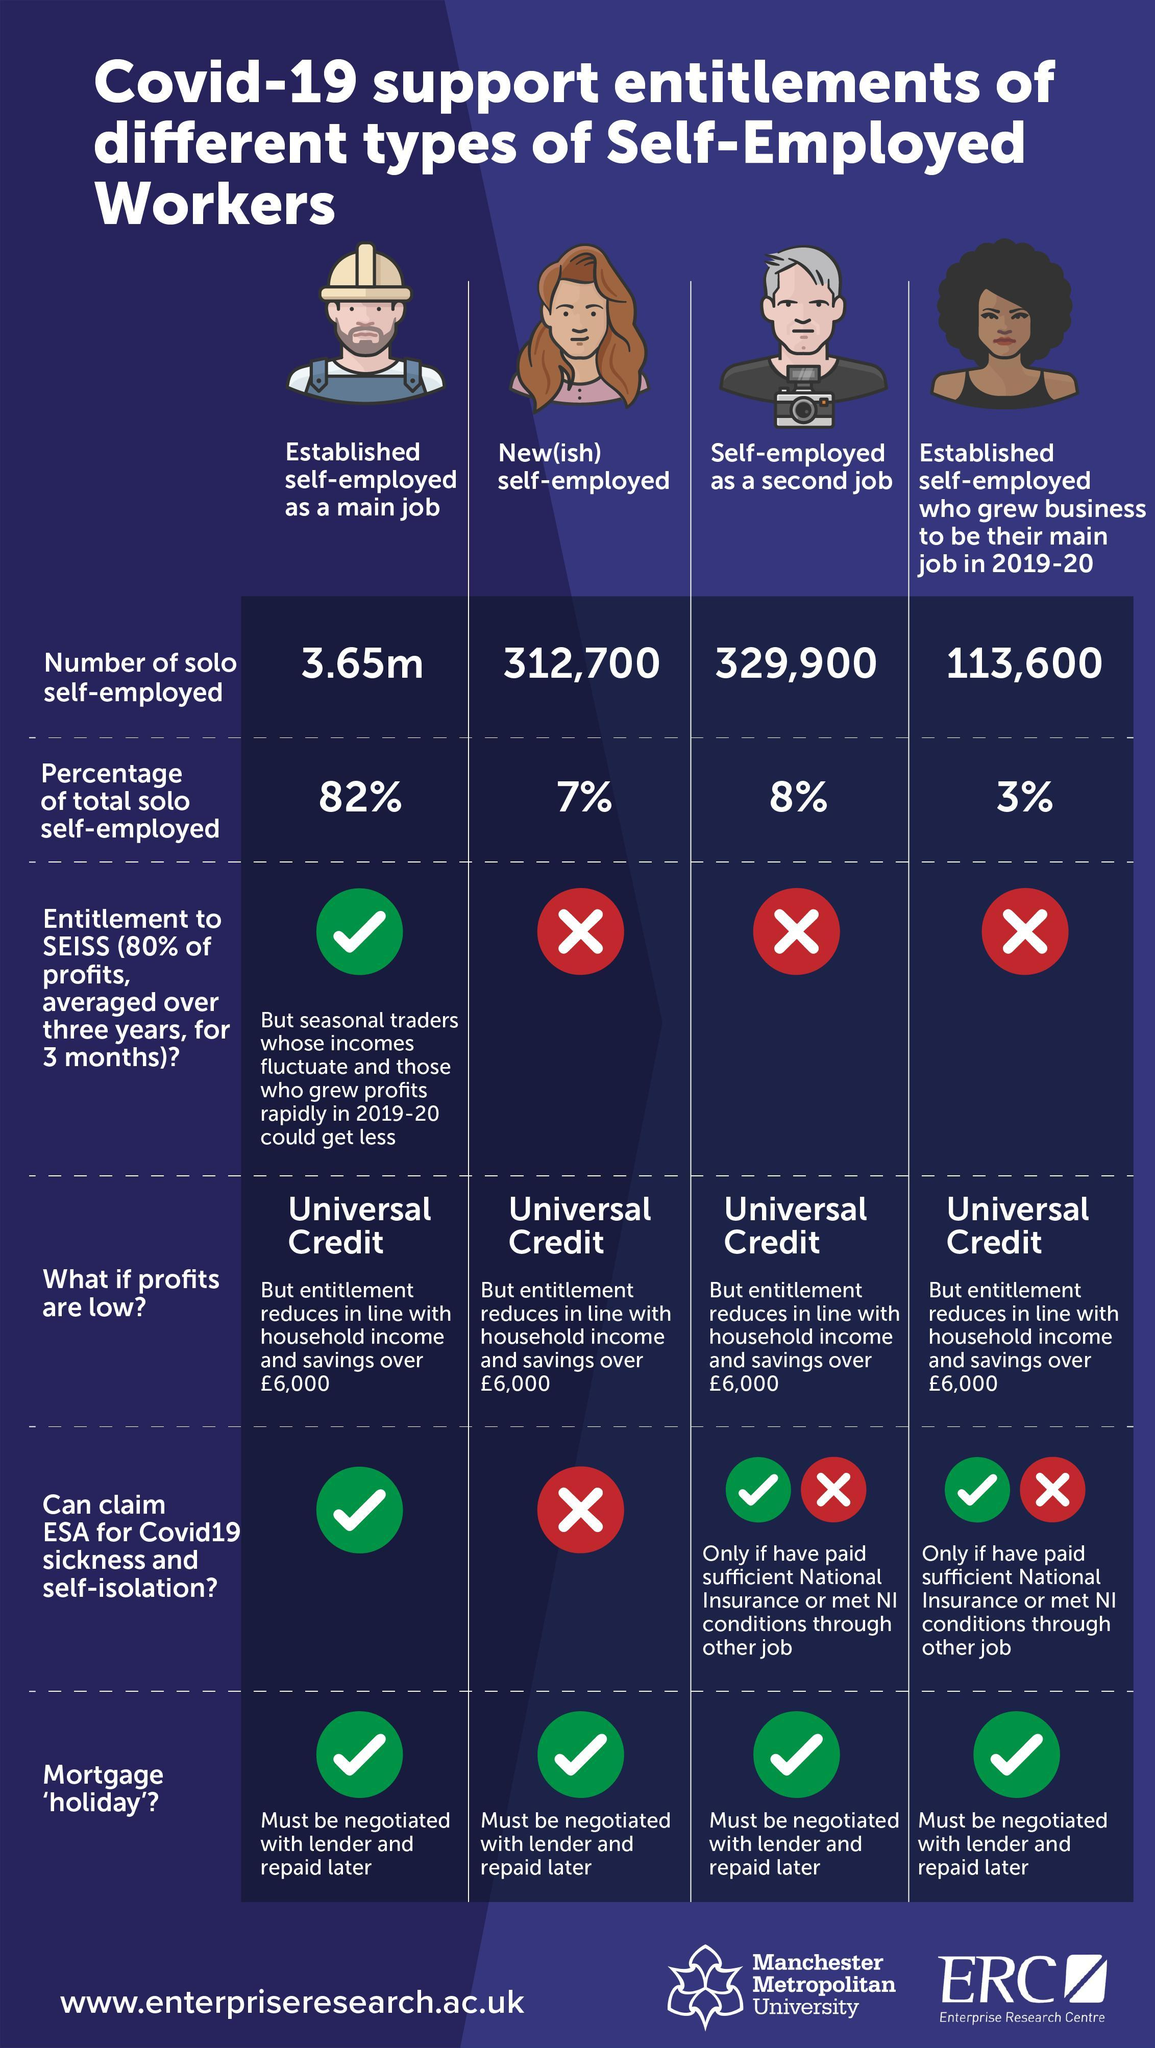who can claim ESA for covid-19 unconditionally?
Answer the question with a short phrase. established self-employed as a main job how many green tick symbols are there in this infographic? 8 what is the title of the second column? new(ish) self-employed the number of workers of which category is highest? established self-employed as a main job Which are the categories who can claim ESA for covid-19 under specific conditions? self-employed as a second job, established self-employed who grew business to be their main job in 2019-20 what is the total count of new self-employed workers and people who are self employed as a  second job? 642600 What is the total percentage of workers who are not an established self-employed(as a main job)? 18% What describes in the second row of the table? percentage of total solo self-employed how many different sub categories of self-employed workers are given in the table? 4 what is the title of the third column? self-employed as a second job who is more in number - new self-employed workers or self-employed as a second job? self-employed as a second job which categories of self-employed workers are not entitled to SESS? new(ish) self-employed, self-employed as a second job, established self-employed who grew business to be their main job 